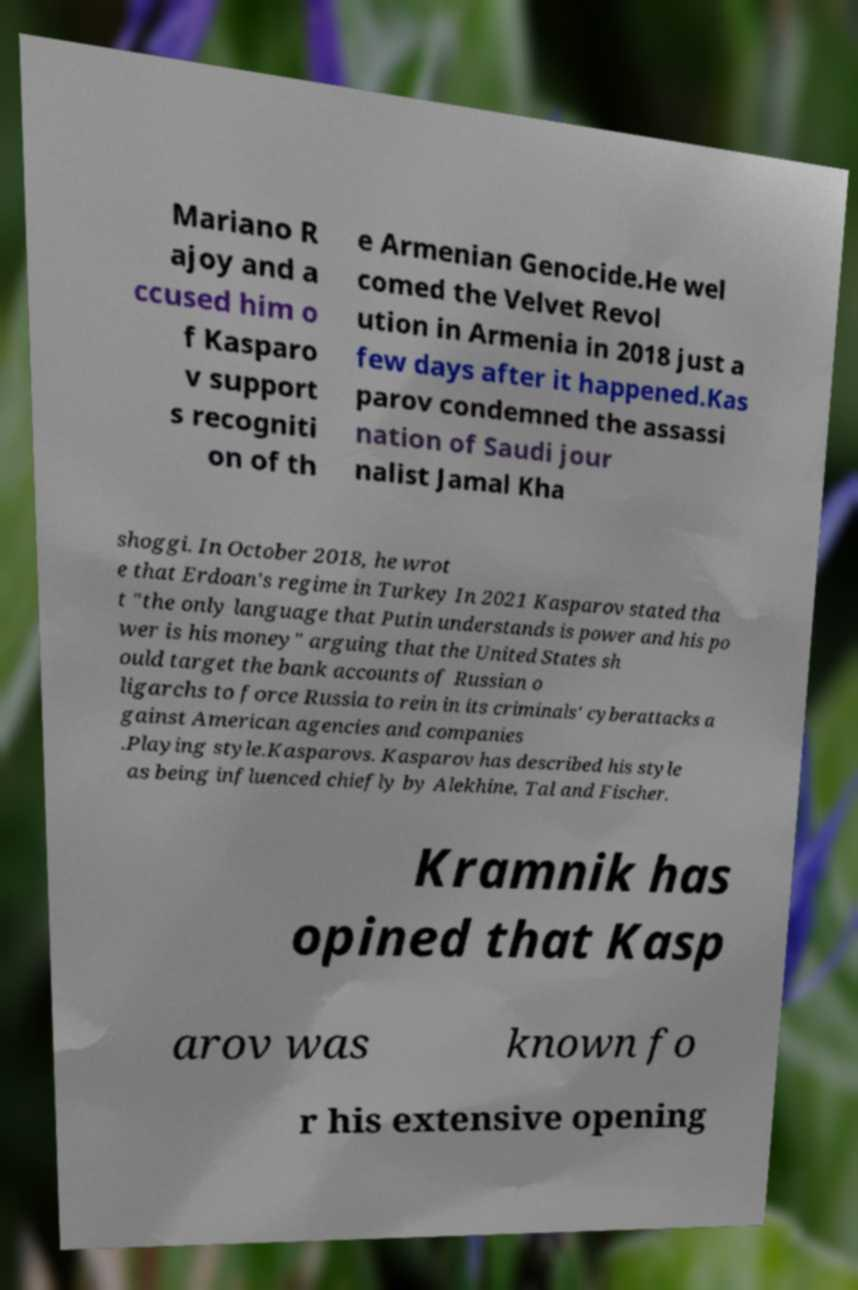Could you extract and type out the text from this image? Mariano R ajoy and a ccused him o f Kasparo v support s recogniti on of th e Armenian Genocide.He wel comed the Velvet Revol ution in Armenia in 2018 just a few days after it happened.Kas parov condemned the assassi nation of Saudi jour nalist Jamal Kha shoggi. In October 2018, he wrot e that Erdoan's regime in Turkey In 2021 Kasparov stated tha t "the only language that Putin understands is power and his po wer is his money" arguing that the United States sh ould target the bank accounts of Russian o ligarchs to force Russia to rein in its criminals' cyberattacks a gainst American agencies and companies .Playing style.Kasparovs. Kasparov has described his style as being influenced chiefly by Alekhine, Tal and Fischer. Kramnik has opined that Kasp arov was known fo r his extensive opening 